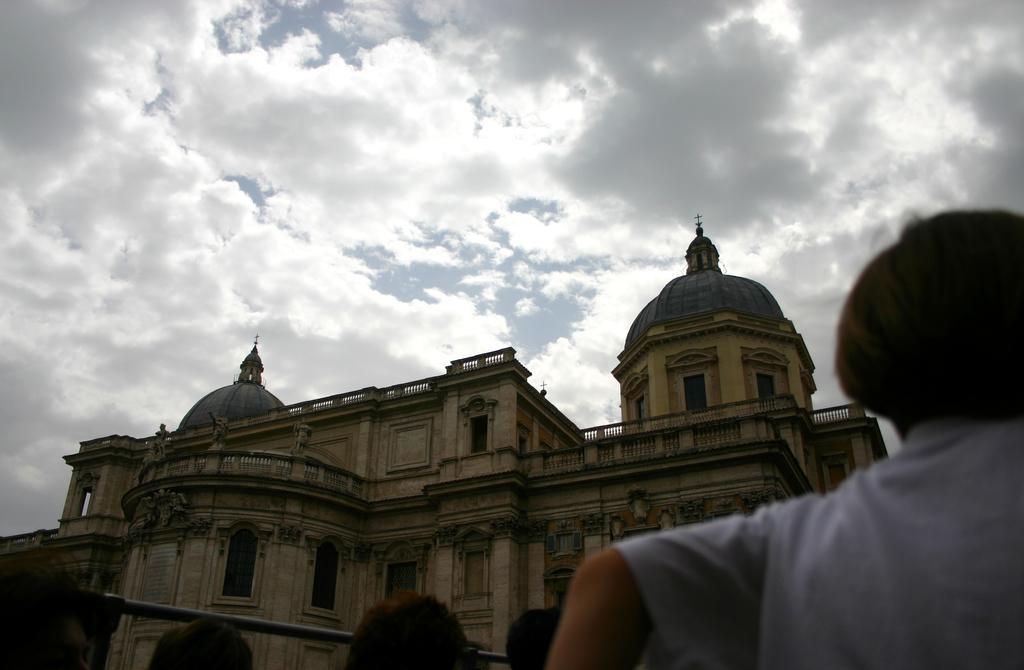In one or two sentences, can you explain what this image depicts? In the center of the image there is a building. At the bottom there are people. In the background there is sky. 